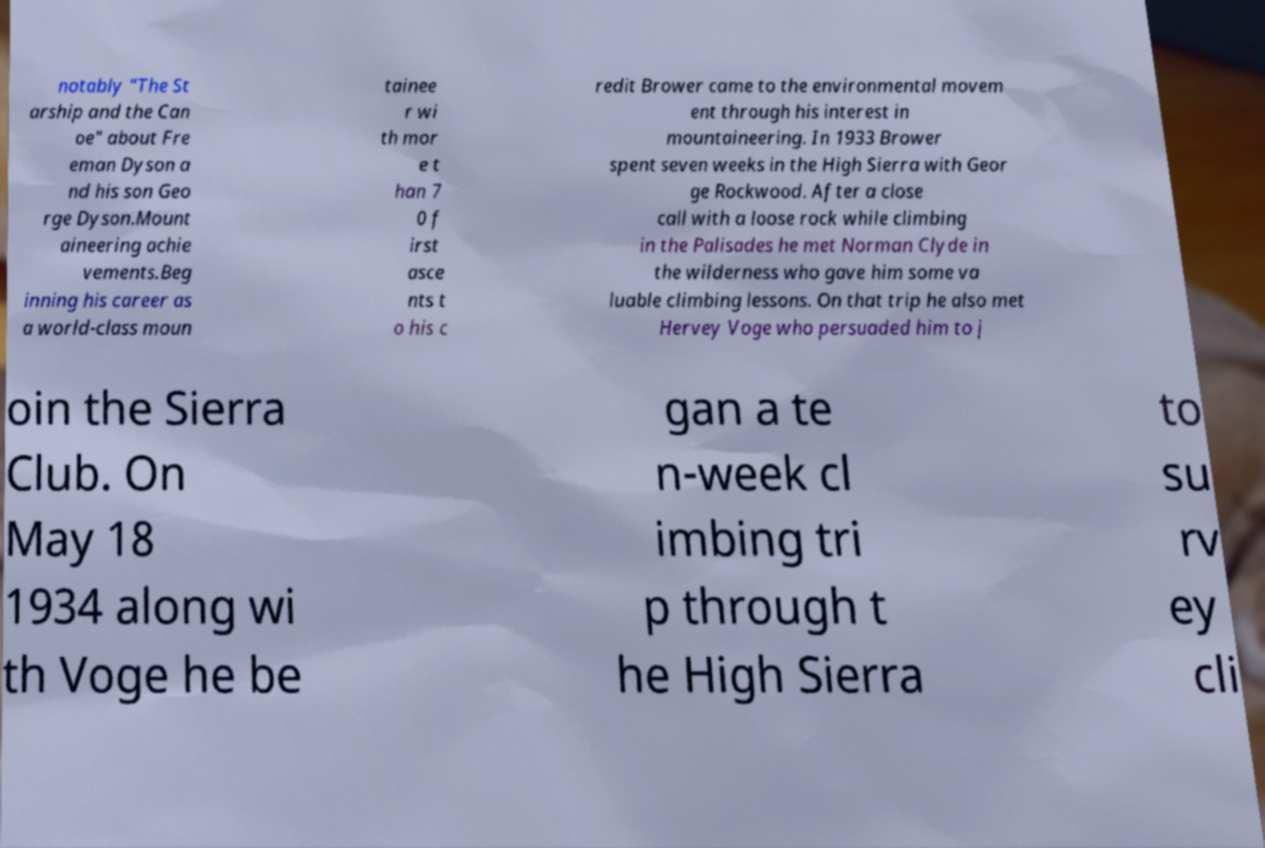Please identify and transcribe the text found in this image. notably "The St arship and the Can oe" about Fre eman Dyson a nd his son Geo rge Dyson.Mount aineering achie vements.Beg inning his career as a world-class moun tainee r wi th mor e t han 7 0 f irst asce nts t o his c redit Brower came to the environmental movem ent through his interest in mountaineering. In 1933 Brower spent seven weeks in the High Sierra with Geor ge Rockwood. After a close call with a loose rock while climbing in the Palisades he met Norman Clyde in the wilderness who gave him some va luable climbing lessons. On that trip he also met Hervey Voge who persuaded him to j oin the Sierra Club. On May 18 1934 along wi th Voge he be gan a te n-week cl imbing tri p through t he High Sierra to su rv ey cli 